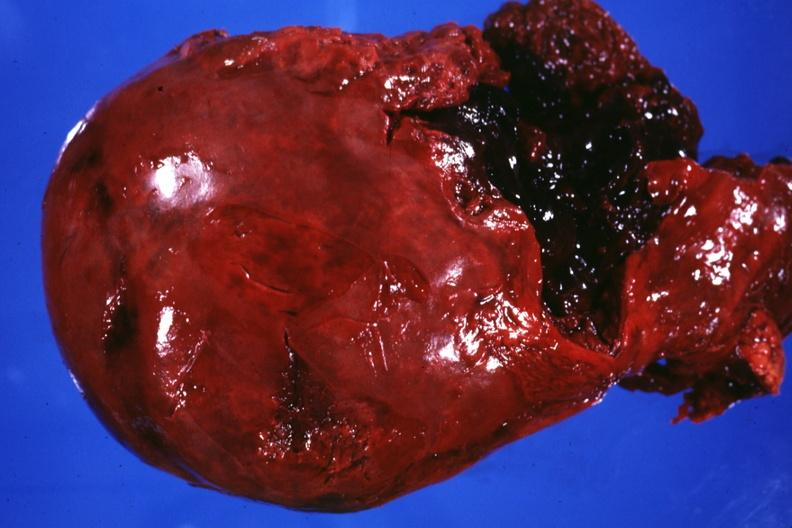what does this image show?
Answer the question using a single word or phrase. External view of liver severe laceration between lobes 